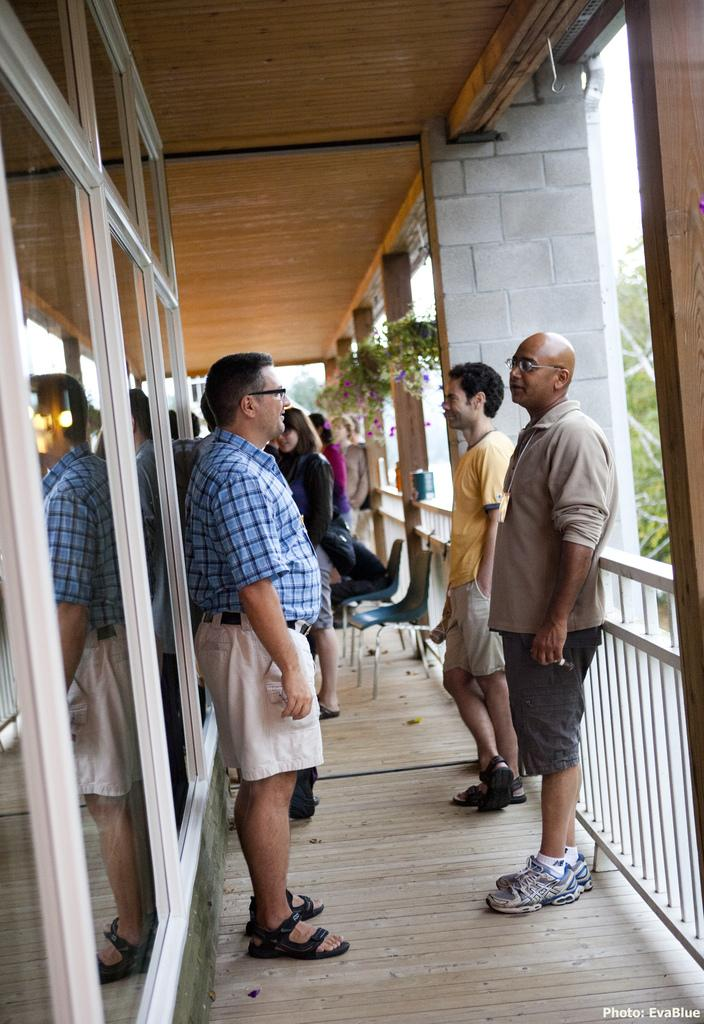What are the people in the image doing? The people in the image are standing in the veranda. What else can be seen in the image besides the people? There are plants in the image. Can you describe the door on the left side of the image? There is a glass door on the left side of the image. What type of tray is being used to shock the plants in the image? There is no tray or shocking of plants depicted in the image. 